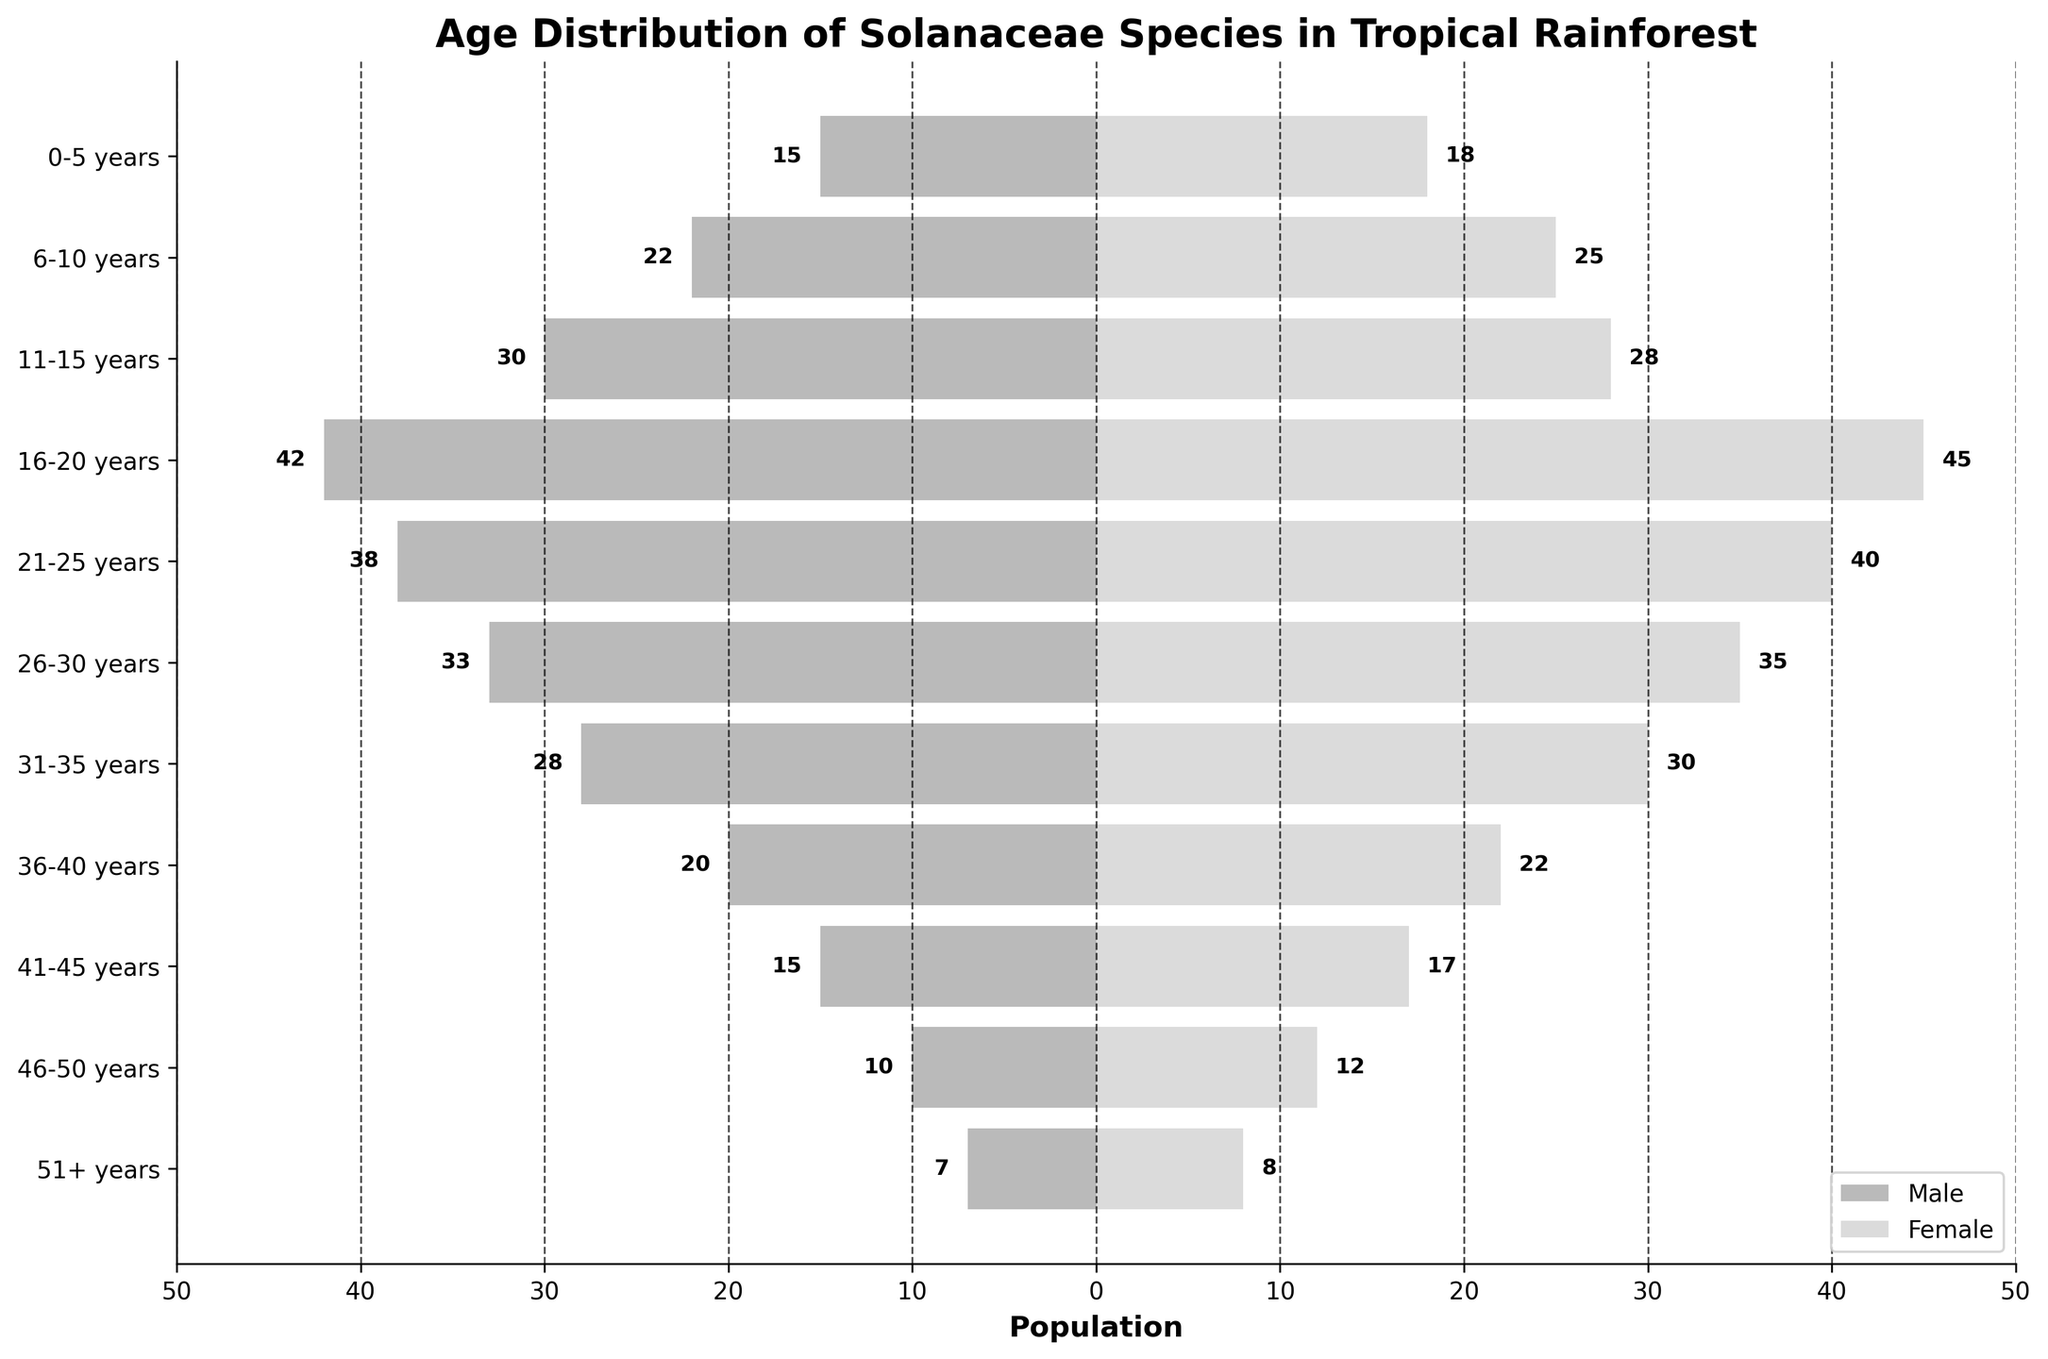What is the title of the figure? The title can be found at the top of the figure. It provides a general description of the plot.
Answer: Age Distribution of Solanaceae Species in Tropical Rainforest How many age groups are displayed on the y-axis? The y-axis contains tick labels for each age group. By counting these labels, we can determine the number of age groups.
Answer: 11 Which age group has the highest population for males? By looking at the length of the bars for males on the left side of the plot, we can determine which one extends the farthest to the left.
Answer: 16-20 years What is the total population of Solanaceae species aged 0-5 years? We need to sum the populations of males and females in the 0-5 years age group. Check the bars for this age group and read off the values.
Answer: 33 Which gender has more individuals in the 31-35 years age group? By comparing the lengths of the male and female bars for the 31-35 years age group, we can determine which one is longer.
Answer: Female What is the difference in population between males and females in the 51+ years age group? Read the values for both genders in the 51+ years age group and calculate the difference. (8 - 7) = 1
Answer: 1 What is the combined population of males and females in the 21-25 years age group? Add the values of the male and female populations for the 21-25 years age group (38 male + 40 female).
Answer: 78 Which age group has the smallest population for females? Identify the bar on the right side of the plot representing females that is the shortest.
Answer: 51+ years What is the average population of males across all age groups? Sum the male values of all age groups and divide by the number of age groups (15 + 22 + 30 + 42 + 38 + 33 + 28 + 20 + 15 + 10 + 7) ÷ 11.
Answer: 26.1 Is there any age group where the male population is equal to the female population? Compare the length of the bars for both genders across all age groups to see if any are equal.
Answer: No 